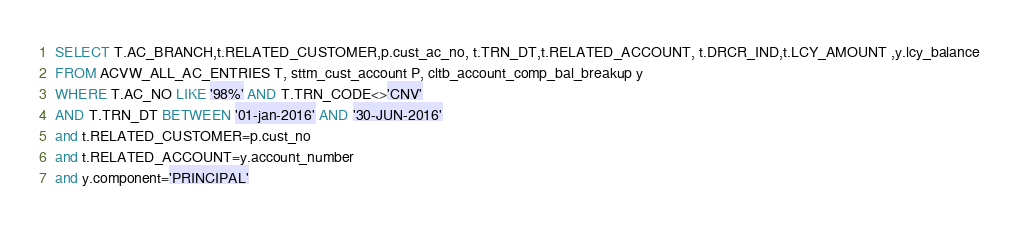Convert code to text. <code><loc_0><loc_0><loc_500><loc_500><_SQL_>SELECT T.AC_BRANCH,t.RELATED_CUSTOMER,p.cust_ac_no, t.TRN_DT,t.RELATED_ACCOUNT, t.DRCR_IND,t.LCY_AMOUNT ,y.lcy_balance
FROM ACVW_ALL_AC_ENTRIES T, sttm_cust_account P, cltb_account_comp_bal_breakup y  
WHERE T.AC_NO LIKE '98%' AND T.TRN_CODE<>'CNV' 
AND T.TRN_DT BETWEEN '01-jan-2016' AND '30-JUN-2016'
and t.RELATED_CUSTOMER=p.cust_no
and t.RELATED_ACCOUNT=y.account_number
and y.component='PRINCIPAL'
</code> 